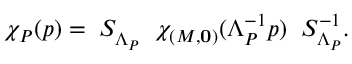Convert formula to latex. <formula><loc_0><loc_0><loc_500><loc_500>\chi _ { P } ( p ) = \, S _ { \Lambda _ { P } } \, \chi _ { ( M , { 0 } ) } ( \Lambda _ { P } ^ { - 1 } p ) \, S _ { \Lambda _ { P } } ^ { - 1 } .</formula> 